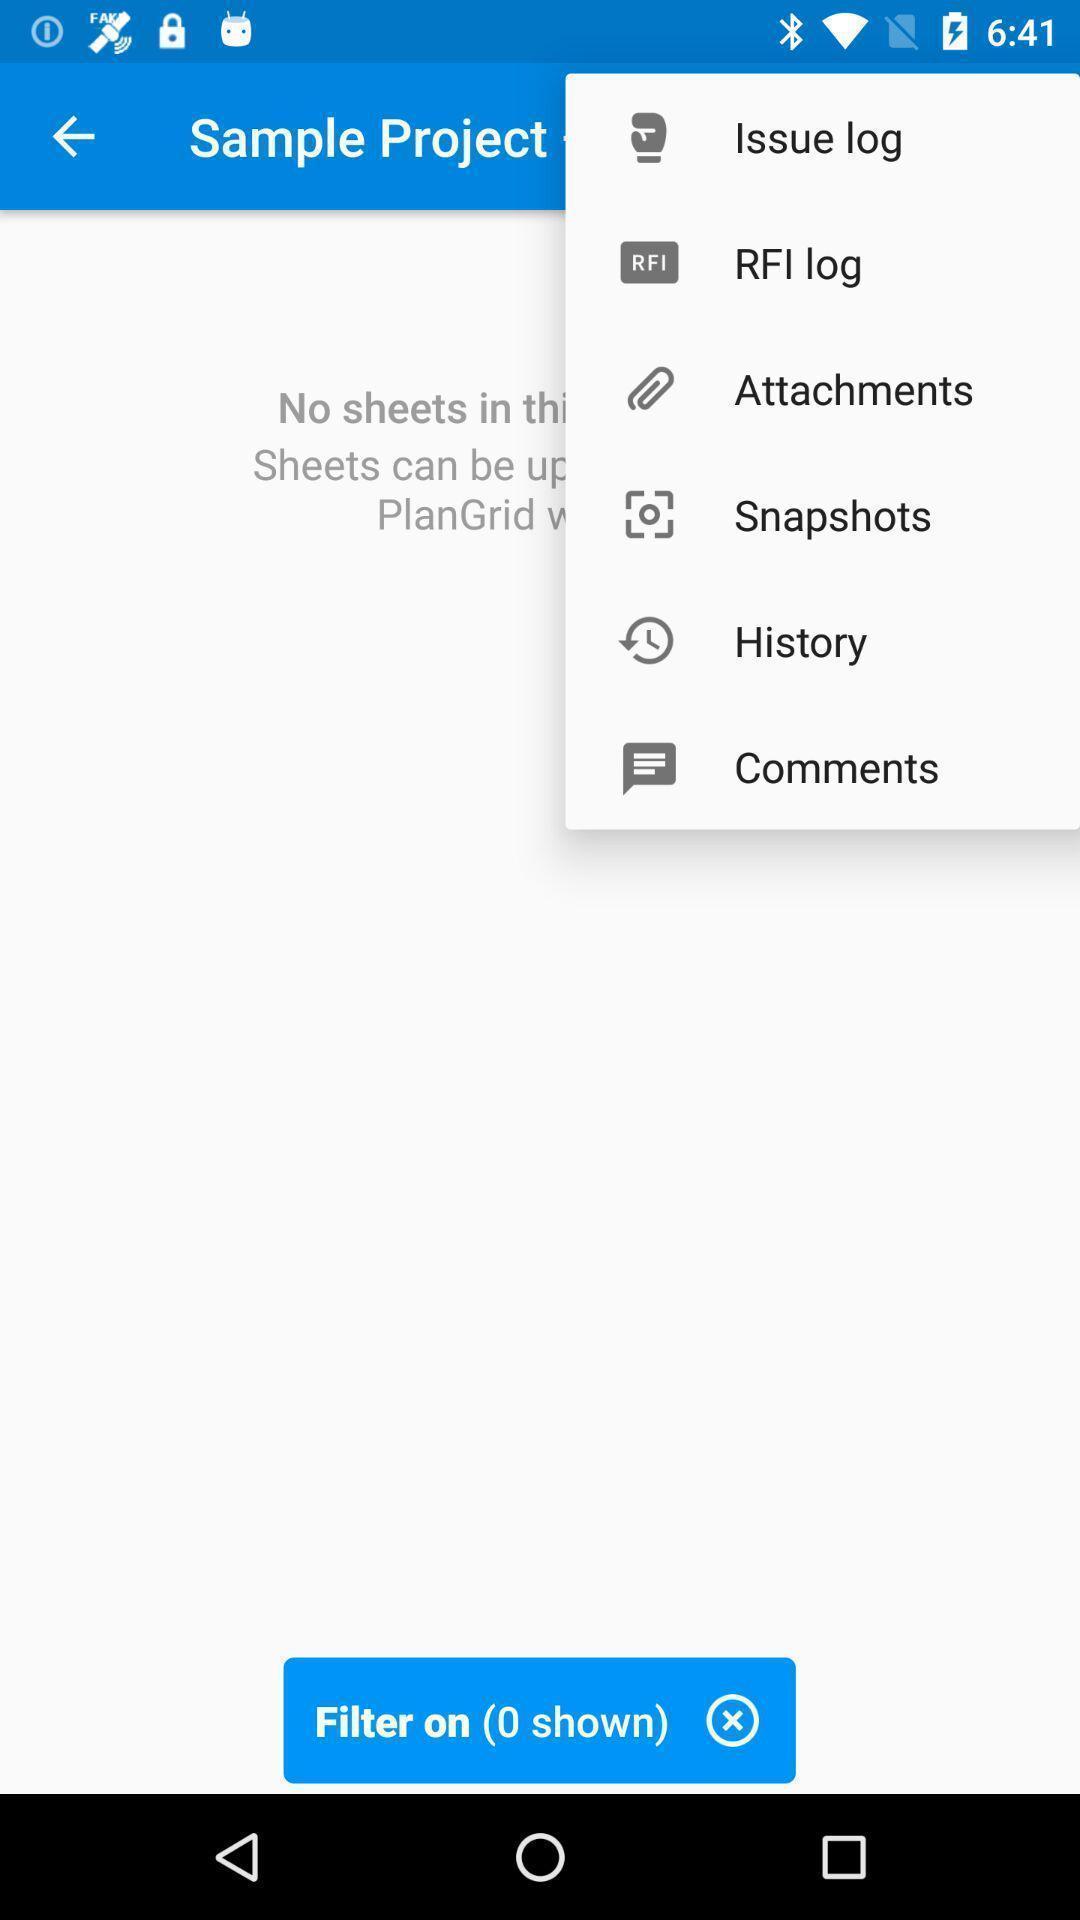What can you discern from this picture? Screen showing issue log and rfi log options. 